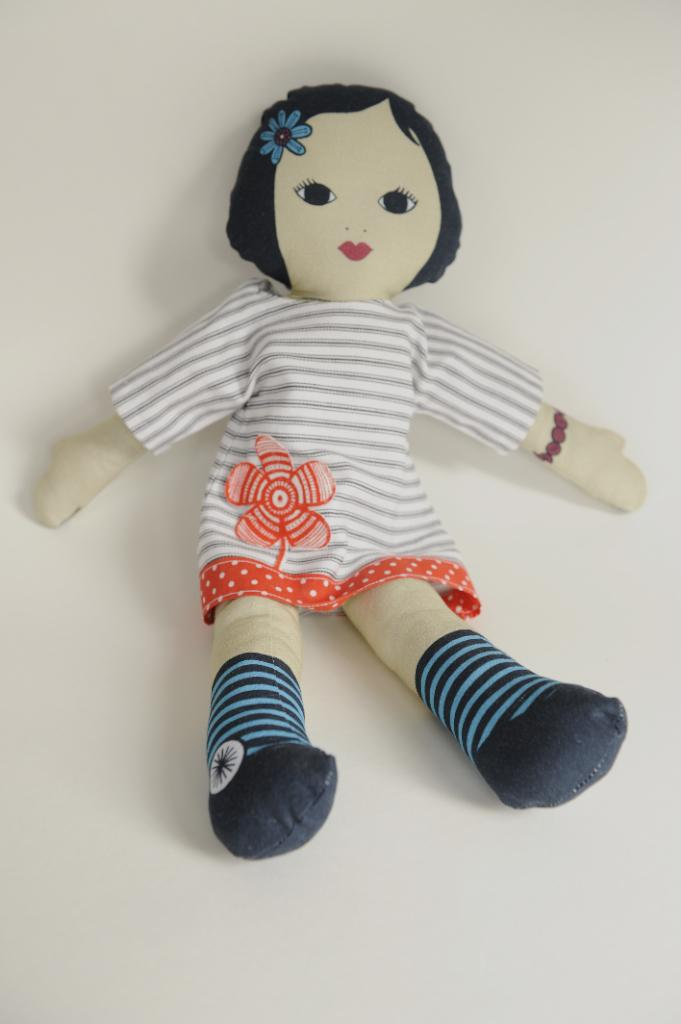What is the main subject in the center of the image? There is a toy in the center of the image. What color is the background of the image? The background of the image is white. Can you explain the humor system used by the waves in the image? There are no waves present in the image, and therefore no humor system can be observed. 